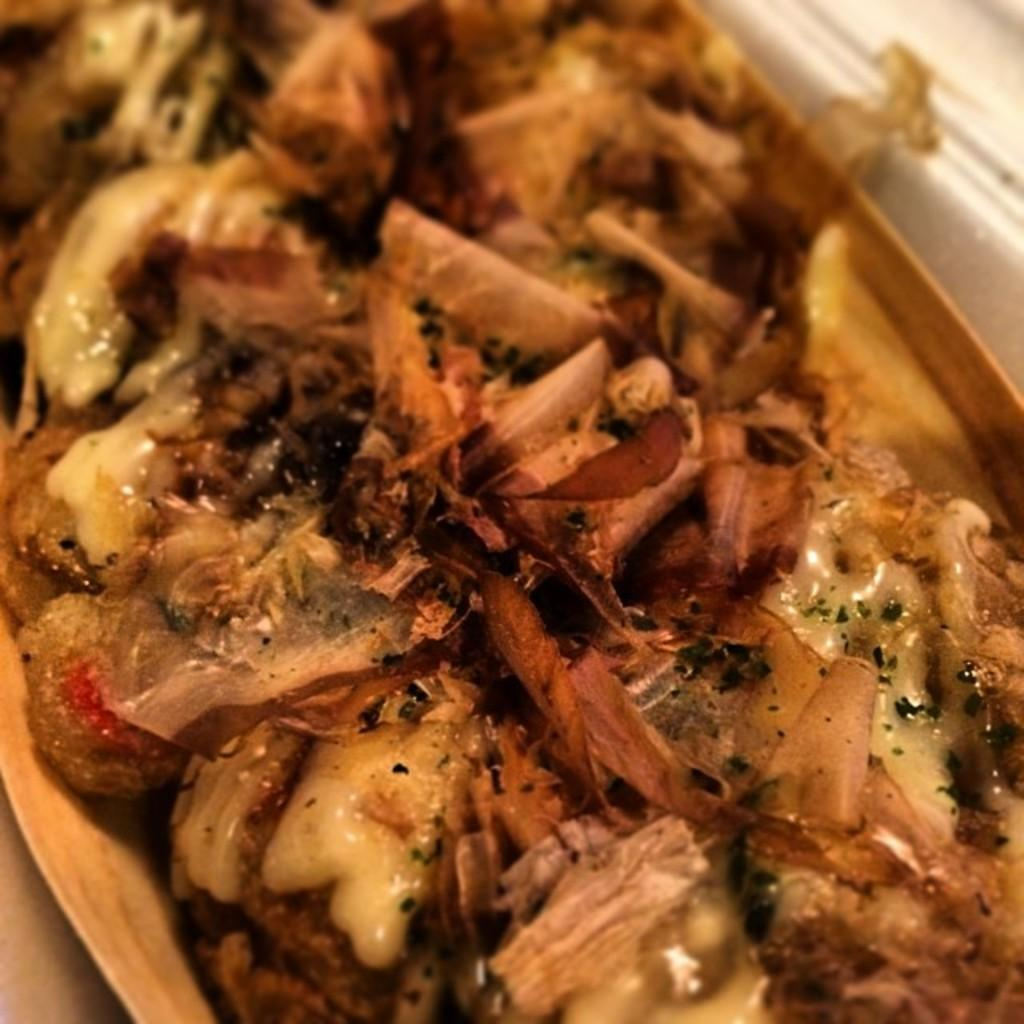What is placed in a bowl in the image? There is a dish in a bowl in the image. What type of question is being asked by the lamp in the image? There is no lamp present in the image, and therefore no such activity can be observed. 